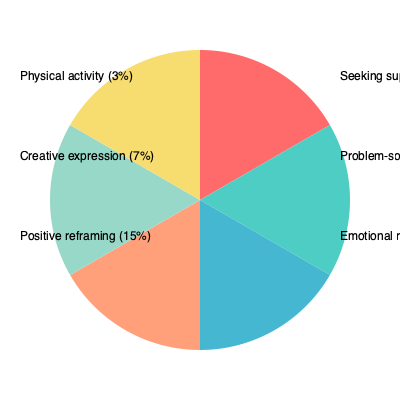Based on the pie chart depicting the most common coping mechanisms used by resilient children who have experienced abuse, what percentage of children use problem-solving as their primary coping strategy? To answer this question, we need to analyze the pie chart and identify the slice representing problem-solving. Here's a step-by-step explanation:

1. Examine the pie chart and its accompanying legend.
2. Locate the slice labeled "Problem-solving" in the legend.
3. Observe that this slice is the second largest in the chart.
4. Read the percentage associated with problem-solving from the legend.
5. The legend indicates that problem-solving accounts for 25% of the coping mechanisms used by resilient children who have experienced abuse.

This information is directly provided in the pie chart, requiring no additional calculations. The chart visually represents the proportion of children using problem-solving as a coping mechanism relative to other strategies.
Answer: 25% 